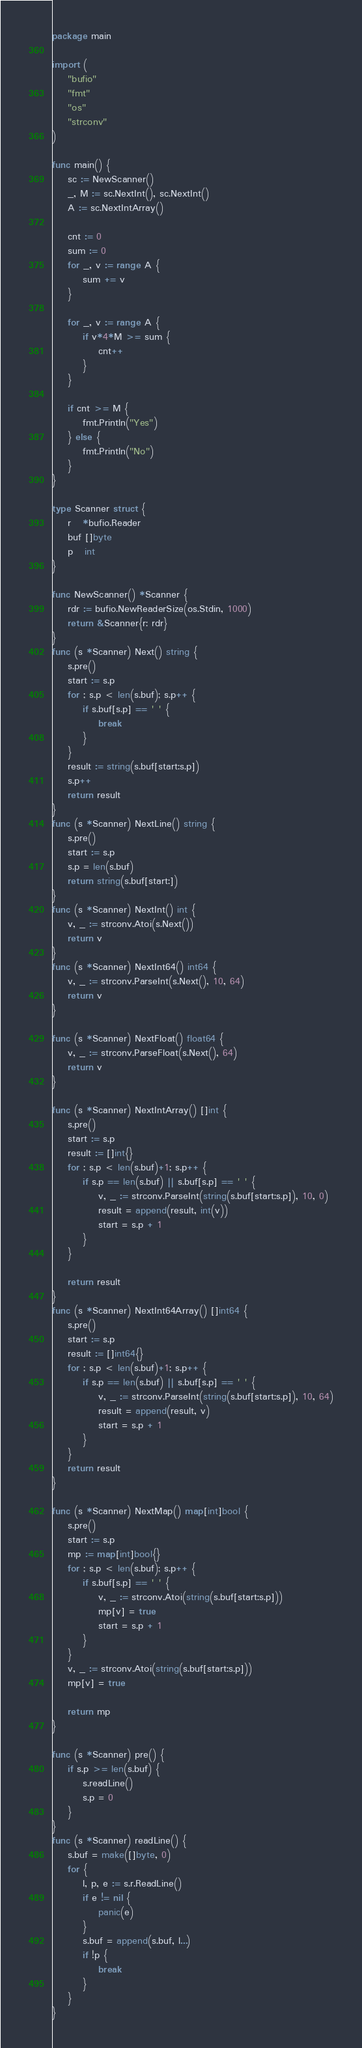<code> <loc_0><loc_0><loc_500><loc_500><_Go_>package main

import (
	"bufio"
	"fmt"
	"os"
	"strconv"
)

func main() {
	sc := NewScanner()
	_, M := sc.NextInt(), sc.NextInt()
	A := sc.NextIntArray()

	cnt := 0
	sum := 0
	for _, v := range A {
		sum += v
	}

	for _, v := range A {
		if v*4*M >= sum {
			cnt++
		}
	}

	if cnt >= M {
		fmt.Println("Yes")
	} else {
		fmt.Println("No")
	}
}

type Scanner struct {
	r   *bufio.Reader
	buf []byte
	p   int
}

func NewScanner() *Scanner {
	rdr := bufio.NewReaderSize(os.Stdin, 1000)
	return &Scanner{r: rdr}
}
func (s *Scanner) Next() string {
	s.pre()
	start := s.p
	for ; s.p < len(s.buf); s.p++ {
		if s.buf[s.p] == ' ' {
			break
		}
	}
	result := string(s.buf[start:s.p])
	s.p++
	return result
}
func (s *Scanner) NextLine() string {
	s.pre()
	start := s.p
	s.p = len(s.buf)
	return string(s.buf[start:])
}
func (s *Scanner) NextInt() int {
	v, _ := strconv.Atoi(s.Next())
	return v
}
func (s *Scanner) NextInt64() int64 {
	v, _ := strconv.ParseInt(s.Next(), 10, 64)
	return v
}

func (s *Scanner) NextFloat() float64 {
	v, _ := strconv.ParseFloat(s.Next(), 64)
	return v
}

func (s *Scanner) NextIntArray() []int {
	s.pre()
	start := s.p
	result := []int{}
	for ; s.p < len(s.buf)+1; s.p++ {
		if s.p == len(s.buf) || s.buf[s.p] == ' ' {
			v, _ := strconv.ParseInt(string(s.buf[start:s.p]), 10, 0)
			result = append(result, int(v))
			start = s.p + 1
		}
	}

	return result
}
func (s *Scanner) NextInt64Array() []int64 {
	s.pre()
	start := s.p
	result := []int64{}
	for ; s.p < len(s.buf)+1; s.p++ {
		if s.p == len(s.buf) || s.buf[s.p] == ' ' {
			v, _ := strconv.ParseInt(string(s.buf[start:s.p]), 10, 64)
			result = append(result, v)
			start = s.p + 1
		}
	}
	return result
}

func (s *Scanner) NextMap() map[int]bool {
	s.pre()
	start := s.p
	mp := map[int]bool{}
	for ; s.p < len(s.buf); s.p++ {
		if s.buf[s.p] == ' ' {
			v, _ := strconv.Atoi(string(s.buf[start:s.p]))
			mp[v] = true
			start = s.p + 1
		}
	}
	v, _ := strconv.Atoi(string(s.buf[start:s.p]))
	mp[v] = true

	return mp
}

func (s *Scanner) pre() {
	if s.p >= len(s.buf) {
		s.readLine()
		s.p = 0
	}
}
func (s *Scanner) readLine() {
	s.buf = make([]byte, 0)
	for {
		l, p, e := s.r.ReadLine()
		if e != nil {
			panic(e)
		}
		s.buf = append(s.buf, l...)
		if !p {
			break
		}
	}
}
</code> 